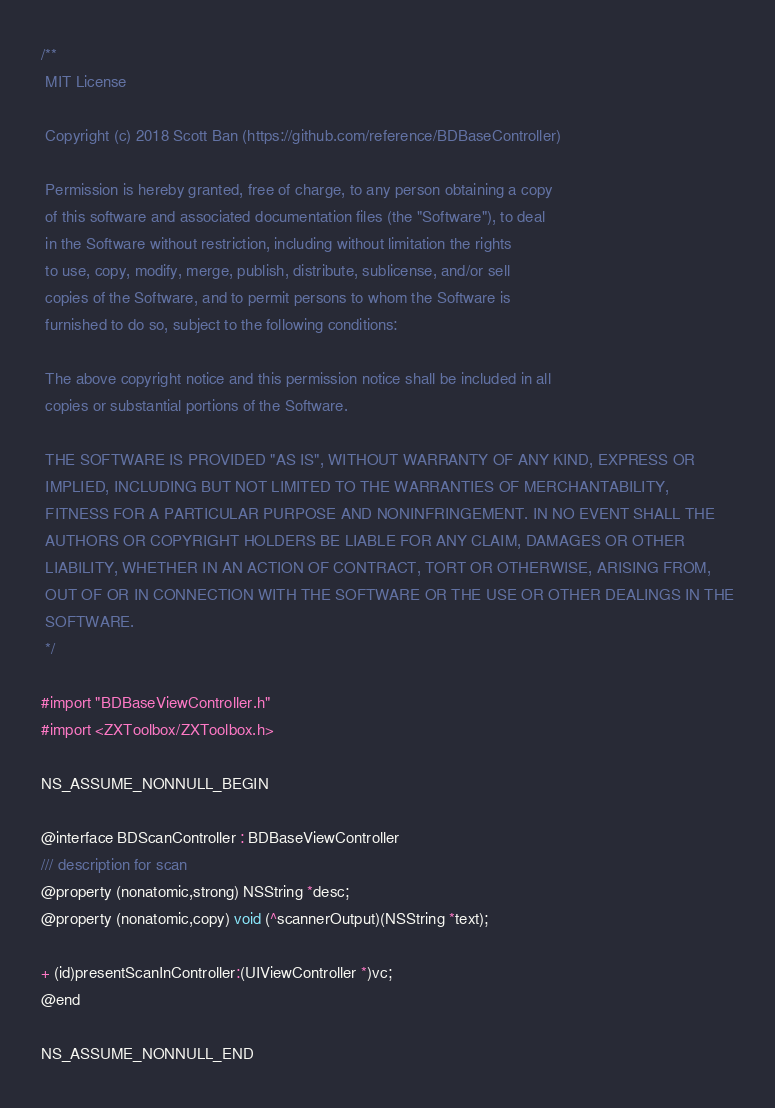<code> <loc_0><loc_0><loc_500><loc_500><_C_>/**
 MIT License
 
 Copyright (c) 2018 Scott Ban (https://github.com/reference/BDBaseController)
 
 Permission is hereby granted, free of charge, to any person obtaining a copy
 of this software and associated documentation files (the "Software"), to deal
 in the Software without restriction, including without limitation the rights
 to use, copy, modify, merge, publish, distribute, sublicense, and/or sell
 copies of the Software, and to permit persons to whom the Software is
 furnished to do so, subject to the following conditions:
 
 The above copyright notice and this permission notice shall be included in all
 copies or substantial portions of the Software.
 
 THE SOFTWARE IS PROVIDED "AS IS", WITHOUT WARRANTY OF ANY KIND, EXPRESS OR
 IMPLIED, INCLUDING BUT NOT LIMITED TO THE WARRANTIES OF MERCHANTABILITY,
 FITNESS FOR A PARTICULAR PURPOSE AND NONINFRINGEMENT. IN NO EVENT SHALL THE
 AUTHORS OR COPYRIGHT HOLDERS BE LIABLE FOR ANY CLAIM, DAMAGES OR OTHER
 LIABILITY, WHETHER IN AN ACTION OF CONTRACT, TORT OR OTHERWISE, ARISING FROM,
 OUT OF OR IN CONNECTION WITH THE SOFTWARE OR THE USE OR OTHER DEALINGS IN THE
 SOFTWARE.
 */

#import "BDBaseViewController.h"
#import <ZXToolbox/ZXToolbox.h>

NS_ASSUME_NONNULL_BEGIN

@interface BDScanController : BDBaseViewController
/// description for scan
@property (nonatomic,strong) NSString *desc;
@property (nonatomic,copy) void (^scannerOutput)(NSString *text);

+ (id)presentScanInController:(UIViewController *)vc;
@end

NS_ASSUME_NONNULL_END
</code> 